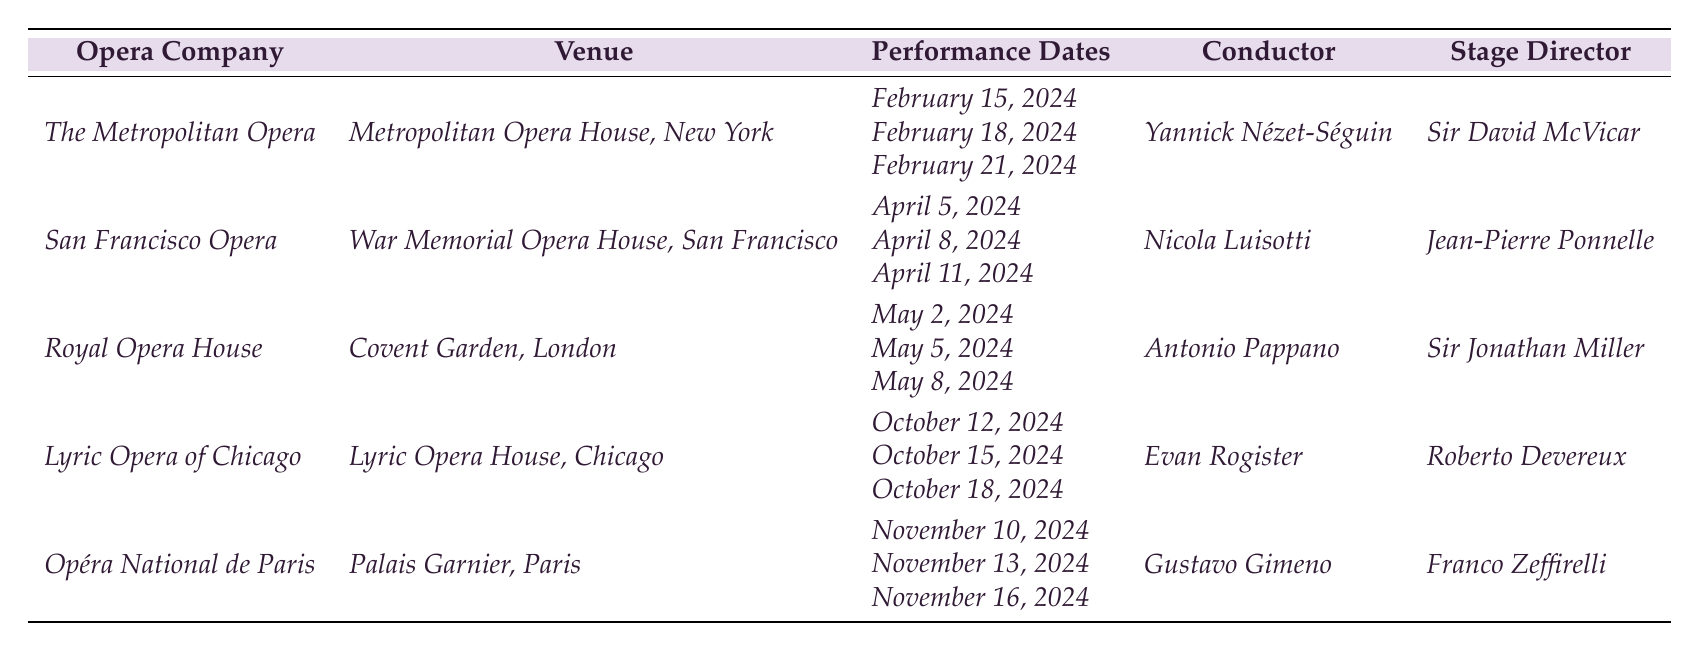What is the venue for the San Francisco Opera production of Tosca? The table lists the venue for the San Francisco Opera production of Tosca as the War Memorial Opera House, San Francisco.
Answer: War Memorial Opera House, San Francisco Who is the conductor for the Tosca performance at the Royal Opera House? According to the table, the conductor for the Tosca performance at the Royal Opera House is Antonio Pappano.
Answer: Antonio Pappano How many performance dates are there for the Tosca production at The Metropolitan Opera? The table shows that there are three performance dates for Tosca at The Metropolitan Opera: February 15, 2024, February 18, 2024, and February 21, 2024.
Answer: 3 Which opera company is staging the last Tosca performance of 2024? The table indicates that the last Tosca performance is staged by the Opéra National de Paris in November 2024, with performance dates on November 10, 13, and 16.
Answer: Opéra National de Paris If you combine all performance dates for Tosca from the table, how many unique dates do you get? The performance dates from all productions are February 15, 18, 21, April 5, 8, 11, May 2, 5, 8, October 12, 15, 18, and November 10, 13, 16. Counting all these gives a total of 12 unique dates.
Answer: 12 Is the conductor for the Tosca production in Chicago also the stage director? The table shows that the conductor for the Lyric Opera of Chicago is Evan Rogister and the stage director is Roberto Devereux, indicating they are different individuals.
Answer: No What is the time interval between the first Tosca performance at The Metropolitan Opera and the first performance at the San Francisco Opera? The first performance at The Metropolitan Opera is on February 15, 2024, and the first performance at the San Francisco Opera is on April 5, 2024. The interval between these dates is 49 days.
Answer: 49 days Which opera company will have performances closest to the start of the year? The first performances are at The Metropolitan Opera on February 15, 2024, which is the earliest among the companies listed, making them the closest to the start of the year.
Answer: The Metropolitan Opera How many different venues are hosting the production of Tosca across all listed companies? The table lists five different venues: Metropolitan Opera House, War Memorial Opera House, Covent Garden, Lyric Opera House, and Palais Garnier, signifying five unique venues for the production of Tosca.
Answer: 5 Where is the venue with the largest seating capacity likely to be, based on the companies listed? While the table does not provide seating capacity, based on common knowledge, the Metropolitan Opera House in New York typically has one of the largest capacities among the venues listed, suggesting it is likely the venue with the largest seating capacity.
Answer: Metropolitan Opera House, New York 